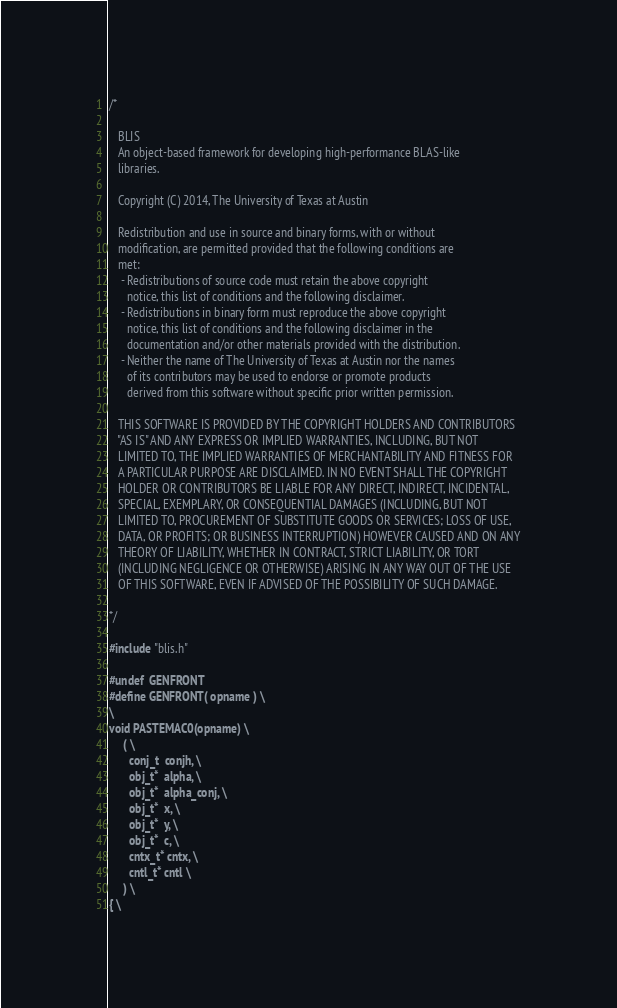Convert code to text. <code><loc_0><loc_0><loc_500><loc_500><_C_>/*

   BLIS    
   An object-based framework for developing high-performance BLAS-like
   libraries.

   Copyright (C) 2014, The University of Texas at Austin

   Redistribution and use in source and binary forms, with or without
   modification, are permitted provided that the following conditions are
   met:
    - Redistributions of source code must retain the above copyright
      notice, this list of conditions and the following disclaimer.
    - Redistributions in binary form must reproduce the above copyright
      notice, this list of conditions and the following disclaimer in the
      documentation and/or other materials provided with the distribution.
    - Neither the name of The University of Texas at Austin nor the names
      of its contributors may be used to endorse or promote products
      derived from this software without specific prior written permission.

   THIS SOFTWARE IS PROVIDED BY THE COPYRIGHT HOLDERS AND CONTRIBUTORS
   "AS IS" AND ANY EXPRESS OR IMPLIED WARRANTIES, INCLUDING, BUT NOT
   LIMITED TO, THE IMPLIED WARRANTIES OF MERCHANTABILITY AND FITNESS FOR
   A PARTICULAR PURPOSE ARE DISCLAIMED. IN NO EVENT SHALL THE COPYRIGHT
   HOLDER OR CONTRIBUTORS BE LIABLE FOR ANY DIRECT, INDIRECT, INCIDENTAL,
   SPECIAL, EXEMPLARY, OR CONSEQUENTIAL DAMAGES (INCLUDING, BUT NOT
   LIMITED TO, PROCUREMENT OF SUBSTITUTE GOODS OR SERVICES; LOSS OF USE,
   DATA, OR PROFITS; OR BUSINESS INTERRUPTION) HOWEVER CAUSED AND ON ANY
   THEORY OF LIABILITY, WHETHER IN CONTRACT, STRICT LIABILITY, OR TORT
   (INCLUDING NEGLIGENCE OR OTHERWISE) ARISING IN ANY WAY OUT OF THE USE
   OF THIS SOFTWARE, EVEN IF ADVISED OF THE POSSIBILITY OF SUCH DAMAGE.

*/

#include "blis.h"

#undef  GENFRONT
#define GENFRONT( opname ) \
\
void PASTEMAC0(opname) \
     ( \
       conj_t  conjh, \
       obj_t*  alpha, \
       obj_t*  alpha_conj, \
       obj_t*  x, \
       obj_t*  y, \
       obj_t*  c, \
       cntx_t* cntx, \
       cntl_t* cntl \
     ) \
{ \</code> 